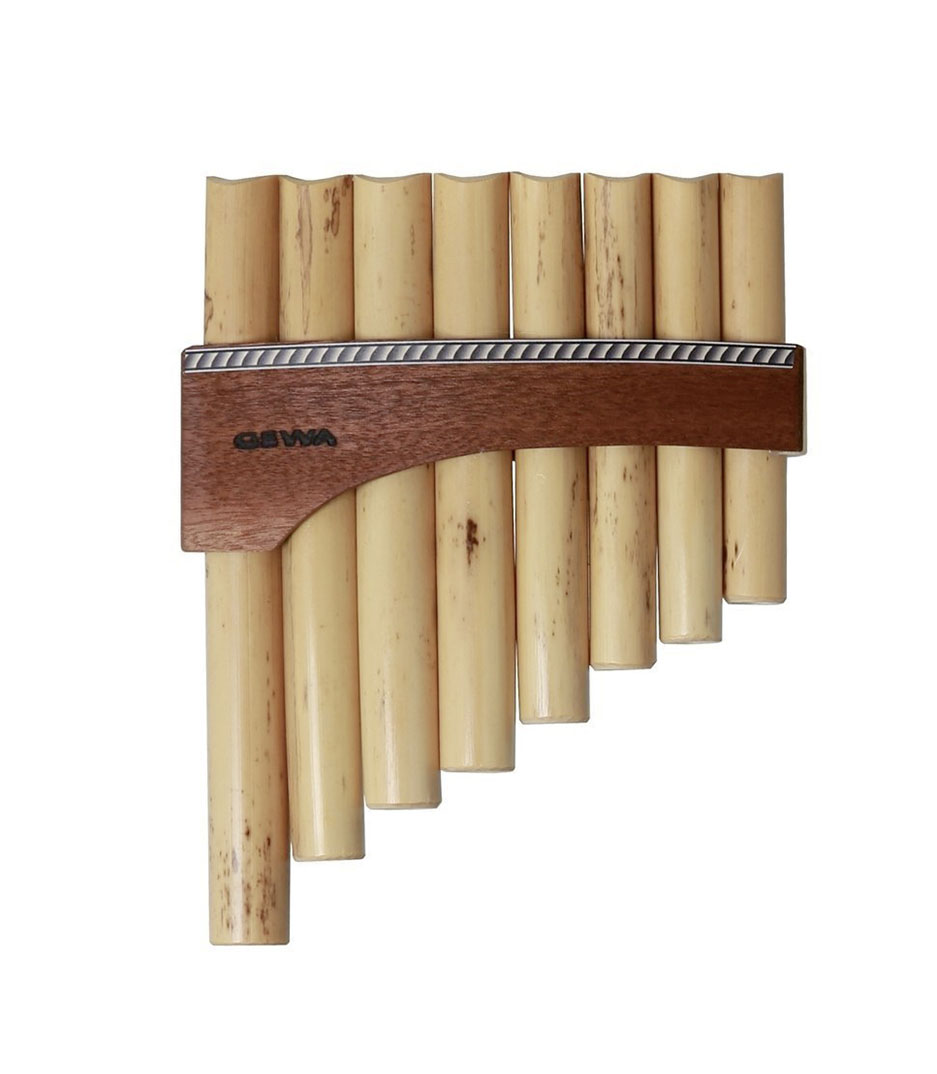This pan flute looks unique. Can you create an instrumental story about it? Once upon a time, nestled in the heart of a mystical forest, there was a pan flute unlike any other. Crafted by a skilled artisan who infused each pipe with the essence of nature, this pan flute had the power to summon the elements. The first pipe called forth the gentle whisper of the wind, while the second summoned the soothing murmur of a nearby stream. As the musician played, the forest would come alive—the trees swayed in harmony, animals gathered in peaceful serenades, and the stars above twinkled in time with the melodies. This pan flute became a symbol of unity between humans and nature, blending their voices in a symphony that echoed through the ages. 